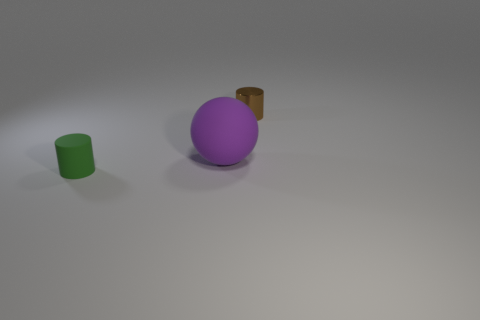Subtract 1 cylinders. How many cylinders are left? 1 Subtract all green cylinders. How many cylinders are left? 1 Add 1 brown objects. How many brown objects are left? 2 Add 2 brown balls. How many brown balls exist? 2 Add 2 small green matte cylinders. How many objects exist? 5 Subtract 0 blue balls. How many objects are left? 3 Subtract all spheres. How many objects are left? 2 Subtract all green spheres. Subtract all brown cylinders. How many spheres are left? 1 Subtract all green rubber cylinders. Subtract all red rubber cylinders. How many objects are left? 2 